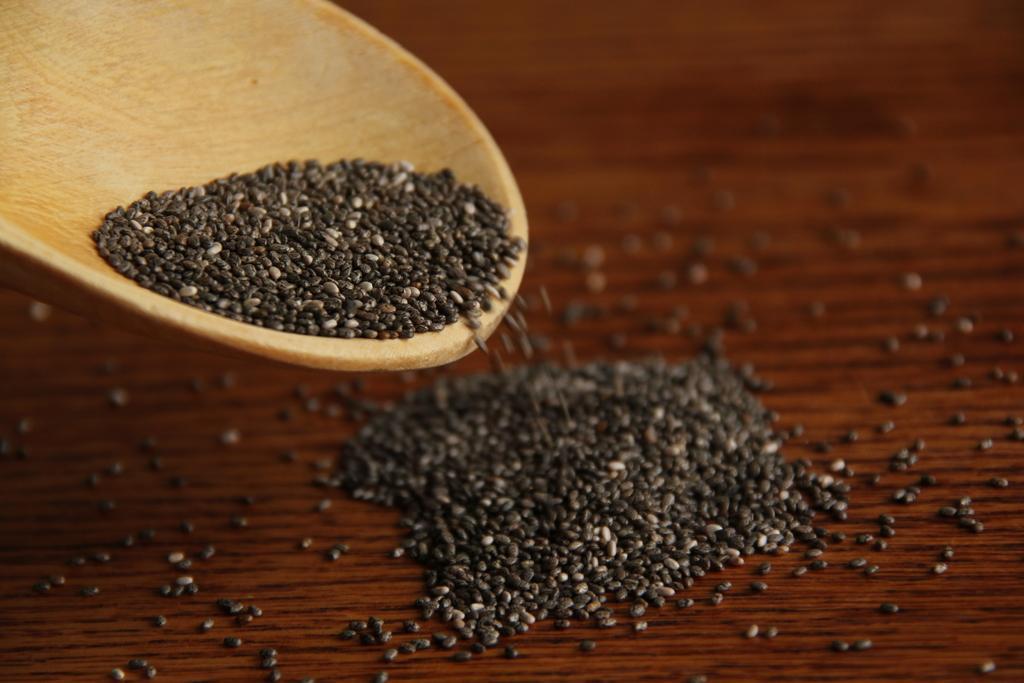How would you summarize this image in a sentence or two? In this image I can see the seeds which are in black and white color. I can see few seeds are in wooden object and few are on the brown color surface. 